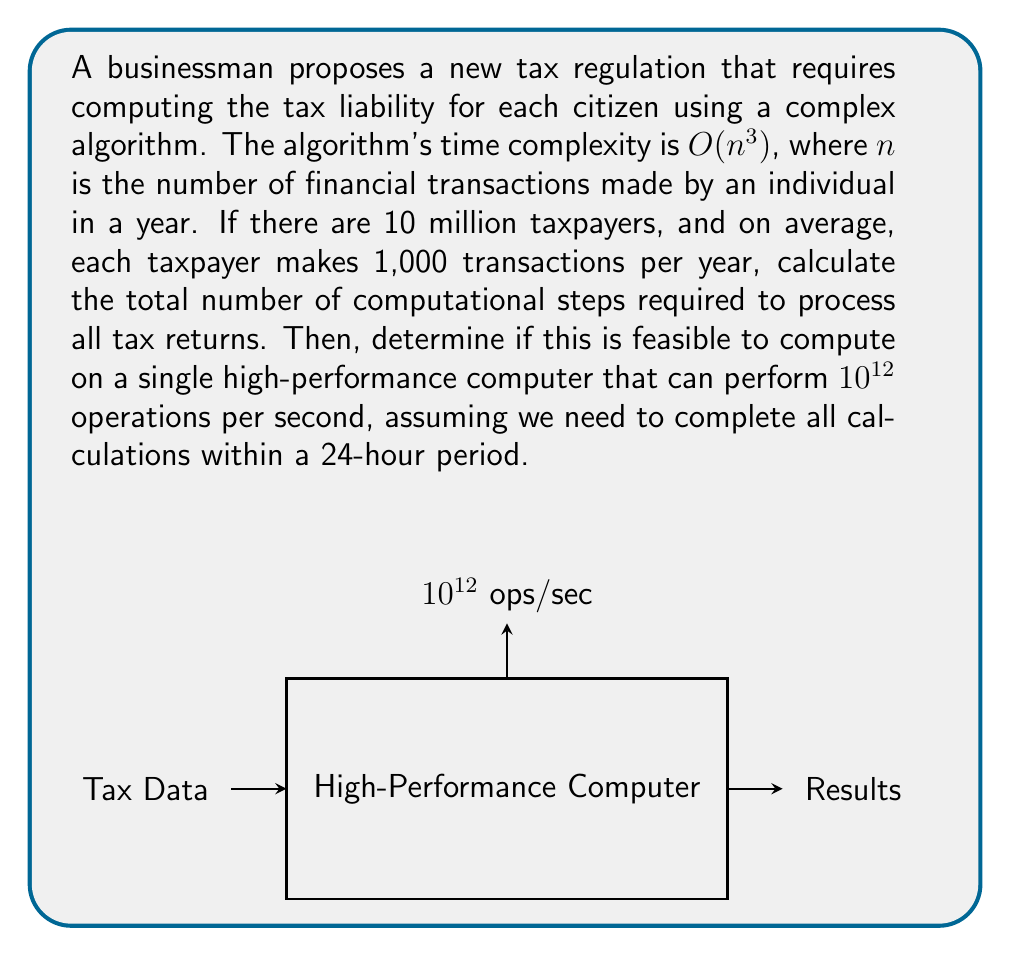Provide a solution to this math problem. Let's approach this step-by-step:

1) First, we need to calculate the number of computational steps for a single taxpayer:
   - Each taxpayer makes 1,000 transactions on average
   - The algorithm's complexity is $O(n^3)$
   - So, for each taxpayer: $1000^3 = 10^9$ computational steps

2) Now, we multiply this by the number of taxpayers:
   - Total steps = $10^9 \times 10^7 = 10^{16}$ computational steps

3) We need to determine if this is feasible within 24 hours on the given computer:
   - The computer can perform $10^{12}$ operations per second
   - In 24 hours, that's: $10^{12} \times 60 \times 60 \times 24 = 8.64 \times 10^{16}$ operations

4) Compare the required computations to the computer's capacity:
   - Required: $10^{16}$ steps
   - Available: $8.64 \times 10^{16}$ operations

5) Feasibility check:
   - The computer can perform more operations in 24 hours than required
   - $8.64 \times 10^{16} > 10^{16}$
   - Therefore, it is computationally feasible

6) Calculate the actual time needed:
   - Time = $\frac{10^{16}}{10^{12}} = 10^4$ seconds
   - $10^4$ seconds = 2.78 hours

Thus, the proposed tax regulation implementation is computationally feasible and can be completed in less than 3 hours on the given high-performance computer.
Answer: Feasible; 2.78 hours 